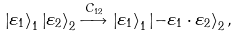<formula> <loc_0><loc_0><loc_500><loc_500>\left | \varepsilon _ { 1 } \right \rangle _ { 1 } \left | \varepsilon _ { 2 } \right \rangle _ { 2 } \stackrel { C _ { 1 2 } } { \longrightarrow } \left | \varepsilon _ { 1 } \right \rangle _ { 1 } \left | - \varepsilon _ { 1 } \cdot \varepsilon _ { 2 } \right \rangle _ { 2 } ,</formula> 